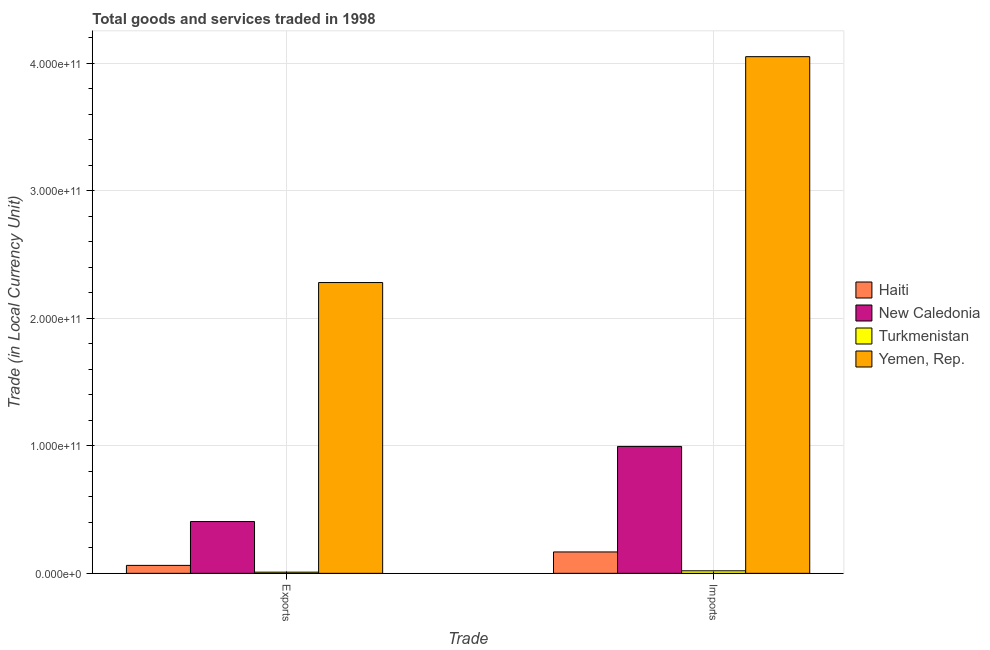Are the number of bars per tick equal to the number of legend labels?
Ensure brevity in your answer.  Yes. Are the number of bars on each tick of the X-axis equal?
Make the answer very short. Yes. How many bars are there on the 2nd tick from the left?
Your response must be concise. 4. How many bars are there on the 1st tick from the right?
Give a very brief answer. 4. What is the label of the 1st group of bars from the left?
Your answer should be compact. Exports. What is the export of goods and services in Turkmenistan?
Ensure brevity in your answer.  9.14e+08. Across all countries, what is the maximum export of goods and services?
Keep it short and to the point. 2.28e+11. Across all countries, what is the minimum imports of goods and services?
Give a very brief answer. 1.98e+09. In which country was the export of goods and services maximum?
Ensure brevity in your answer.  Yemen, Rep. In which country was the imports of goods and services minimum?
Your answer should be very brief. Turkmenistan. What is the total export of goods and services in the graph?
Your answer should be very brief. 2.76e+11. What is the difference between the imports of goods and services in Yemen, Rep. and that in New Caledonia?
Provide a short and direct response. 3.06e+11. What is the difference between the export of goods and services in Yemen, Rep. and the imports of goods and services in New Caledonia?
Provide a short and direct response. 1.29e+11. What is the average export of goods and services per country?
Your response must be concise. 6.90e+1. What is the difference between the imports of goods and services and export of goods and services in Turkmenistan?
Your answer should be compact. 1.07e+09. What is the ratio of the export of goods and services in New Caledonia to that in Yemen, Rep.?
Offer a terse response. 0.18. Is the export of goods and services in New Caledonia less than that in Yemen, Rep.?
Keep it short and to the point. Yes. In how many countries, is the imports of goods and services greater than the average imports of goods and services taken over all countries?
Provide a succinct answer. 1. What does the 2nd bar from the left in Exports represents?
Offer a terse response. New Caledonia. What does the 2nd bar from the right in Exports represents?
Your answer should be very brief. Turkmenistan. How many bars are there?
Provide a succinct answer. 8. What is the difference between two consecutive major ticks on the Y-axis?
Your answer should be compact. 1.00e+11. Are the values on the major ticks of Y-axis written in scientific E-notation?
Provide a short and direct response. Yes. Does the graph contain grids?
Your answer should be compact. Yes. How many legend labels are there?
Offer a very short reply. 4. What is the title of the graph?
Your response must be concise. Total goods and services traded in 1998. What is the label or title of the X-axis?
Your answer should be compact. Trade. What is the label or title of the Y-axis?
Offer a terse response. Trade (in Local Currency Unit). What is the Trade (in Local Currency Unit) of Haiti in Exports?
Keep it short and to the point. 6.24e+09. What is the Trade (in Local Currency Unit) of New Caledonia in Exports?
Offer a terse response. 4.06e+1. What is the Trade (in Local Currency Unit) of Turkmenistan in Exports?
Offer a terse response. 9.14e+08. What is the Trade (in Local Currency Unit) in Yemen, Rep. in Exports?
Your answer should be very brief. 2.28e+11. What is the Trade (in Local Currency Unit) in Haiti in Imports?
Provide a succinct answer. 1.68e+1. What is the Trade (in Local Currency Unit) of New Caledonia in Imports?
Give a very brief answer. 9.95e+1. What is the Trade (in Local Currency Unit) of Turkmenistan in Imports?
Give a very brief answer. 1.98e+09. What is the Trade (in Local Currency Unit) of Yemen, Rep. in Imports?
Keep it short and to the point. 4.05e+11. Across all Trade, what is the maximum Trade (in Local Currency Unit) in Haiti?
Make the answer very short. 1.68e+1. Across all Trade, what is the maximum Trade (in Local Currency Unit) of New Caledonia?
Ensure brevity in your answer.  9.95e+1. Across all Trade, what is the maximum Trade (in Local Currency Unit) of Turkmenistan?
Provide a succinct answer. 1.98e+09. Across all Trade, what is the maximum Trade (in Local Currency Unit) of Yemen, Rep.?
Your answer should be very brief. 4.05e+11. Across all Trade, what is the minimum Trade (in Local Currency Unit) in Haiti?
Provide a succinct answer. 6.24e+09. Across all Trade, what is the minimum Trade (in Local Currency Unit) in New Caledonia?
Your response must be concise. 4.06e+1. Across all Trade, what is the minimum Trade (in Local Currency Unit) in Turkmenistan?
Make the answer very short. 9.14e+08. Across all Trade, what is the minimum Trade (in Local Currency Unit) in Yemen, Rep.?
Make the answer very short. 2.28e+11. What is the total Trade (in Local Currency Unit) of Haiti in the graph?
Keep it short and to the point. 2.30e+1. What is the total Trade (in Local Currency Unit) of New Caledonia in the graph?
Make the answer very short. 1.40e+11. What is the total Trade (in Local Currency Unit) in Turkmenistan in the graph?
Offer a very short reply. 2.90e+09. What is the total Trade (in Local Currency Unit) in Yemen, Rep. in the graph?
Your response must be concise. 6.33e+11. What is the difference between the Trade (in Local Currency Unit) of Haiti in Exports and that in Imports?
Ensure brevity in your answer.  -1.05e+1. What is the difference between the Trade (in Local Currency Unit) of New Caledonia in Exports and that in Imports?
Provide a short and direct response. -5.89e+1. What is the difference between the Trade (in Local Currency Unit) in Turkmenistan in Exports and that in Imports?
Provide a succinct answer. -1.07e+09. What is the difference between the Trade (in Local Currency Unit) in Yemen, Rep. in Exports and that in Imports?
Your answer should be compact. -1.77e+11. What is the difference between the Trade (in Local Currency Unit) of Haiti in Exports and the Trade (in Local Currency Unit) of New Caledonia in Imports?
Your answer should be compact. -9.33e+1. What is the difference between the Trade (in Local Currency Unit) in Haiti in Exports and the Trade (in Local Currency Unit) in Turkmenistan in Imports?
Provide a succinct answer. 4.26e+09. What is the difference between the Trade (in Local Currency Unit) in Haiti in Exports and the Trade (in Local Currency Unit) in Yemen, Rep. in Imports?
Your answer should be compact. -3.99e+11. What is the difference between the Trade (in Local Currency Unit) in New Caledonia in Exports and the Trade (in Local Currency Unit) in Turkmenistan in Imports?
Provide a short and direct response. 3.86e+1. What is the difference between the Trade (in Local Currency Unit) in New Caledonia in Exports and the Trade (in Local Currency Unit) in Yemen, Rep. in Imports?
Your response must be concise. -3.65e+11. What is the difference between the Trade (in Local Currency Unit) in Turkmenistan in Exports and the Trade (in Local Currency Unit) in Yemen, Rep. in Imports?
Provide a short and direct response. -4.04e+11. What is the average Trade (in Local Currency Unit) of Haiti per Trade?
Provide a succinct answer. 1.15e+1. What is the average Trade (in Local Currency Unit) in New Caledonia per Trade?
Your response must be concise. 7.01e+1. What is the average Trade (in Local Currency Unit) of Turkmenistan per Trade?
Offer a very short reply. 1.45e+09. What is the average Trade (in Local Currency Unit) in Yemen, Rep. per Trade?
Offer a very short reply. 3.17e+11. What is the difference between the Trade (in Local Currency Unit) of Haiti and Trade (in Local Currency Unit) of New Caledonia in Exports?
Offer a terse response. -3.44e+1. What is the difference between the Trade (in Local Currency Unit) in Haiti and Trade (in Local Currency Unit) in Turkmenistan in Exports?
Provide a short and direct response. 5.32e+09. What is the difference between the Trade (in Local Currency Unit) of Haiti and Trade (in Local Currency Unit) of Yemen, Rep. in Exports?
Your answer should be compact. -2.22e+11. What is the difference between the Trade (in Local Currency Unit) of New Caledonia and Trade (in Local Currency Unit) of Turkmenistan in Exports?
Provide a succinct answer. 3.97e+1. What is the difference between the Trade (in Local Currency Unit) of New Caledonia and Trade (in Local Currency Unit) of Yemen, Rep. in Exports?
Offer a terse response. -1.87e+11. What is the difference between the Trade (in Local Currency Unit) in Turkmenistan and Trade (in Local Currency Unit) in Yemen, Rep. in Exports?
Your response must be concise. -2.27e+11. What is the difference between the Trade (in Local Currency Unit) in Haiti and Trade (in Local Currency Unit) in New Caledonia in Imports?
Ensure brevity in your answer.  -8.28e+1. What is the difference between the Trade (in Local Currency Unit) in Haiti and Trade (in Local Currency Unit) in Turkmenistan in Imports?
Provide a short and direct response. 1.48e+1. What is the difference between the Trade (in Local Currency Unit) in Haiti and Trade (in Local Currency Unit) in Yemen, Rep. in Imports?
Provide a succinct answer. -3.88e+11. What is the difference between the Trade (in Local Currency Unit) of New Caledonia and Trade (in Local Currency Unit) of Turkmenistan in Imports?
Your answer should be compact. 9.75e+1. What is the difference between the Trade (in Local Currency Unit) in New Caledonia and Trade (in Local Currency Unit) in Yemen, Rep. in Imports?
Ensure brevity in your answer.  -3.06e+11. What is the difference between the Trade (in Local Currency Unit) in Turkmenistan and Trade (in Local Currency Unit) in Yemen, Rep. in Imports?
Provide a succinct answer. -4.03e+11. What is the ratio of the Trade (in Local Currency Unit) in Haiti in Exports to that in Imports?
Offer a very short reply. 0.37. What is the ratio of the Trade (in Local Currency Unit) of New Caledonia in Exports to that in Imports?
Ensure brevity in your answer.  0.41. What is the ratio of the Trade (in Local Currency Unit) in Turkmenistan in Exports to that in Imports?
Keep it short and to the point. 0.46. What is the ratio of the Trade (in Local Currency Unit) of Yemen, Rep. in Exports to that in Imports?
Keep it short and to the point. 0.56. What is the difference between the highest and the second highest Trade (in Local Currency Unit) in Haiti?
Make the answer very short. 1.05e+1. What is the difference between the highest and the second highest Trade (in Local Currency Unit) of New Caledonia?
Offer a very short reply. 5.89e+1. What is the difference between the highest and the second highest Trade (in Local Currency Unit) in Turkmenistan?
Make the answer very short. 1.07e+09. What is the difference between the highest and the second highest Trade (in Local Currency Unit) in Yemen, Rep.?
Offer a very short reply. 1.77e+11. What is the difference between the highest and the lowest Trade (in Local Currency Unit) in Haiti?
Offer a very short reply. 1.05e+1. What is the difference between the highest and the lowest Trade (in Local Currency Unit) of New Caledonia?
Keep it short and to the point. 5.89e+1. What is the difference between the highest and the lowest Trade (in Local Currency Unit) in Turkmenistan?
Make the answer very short. 1.07e+09. What is the difference between the highest and the lowest Trade (in Local Currency Unit) of Yemen, Rep.?
Offer a terse response. 1.77e+11. 